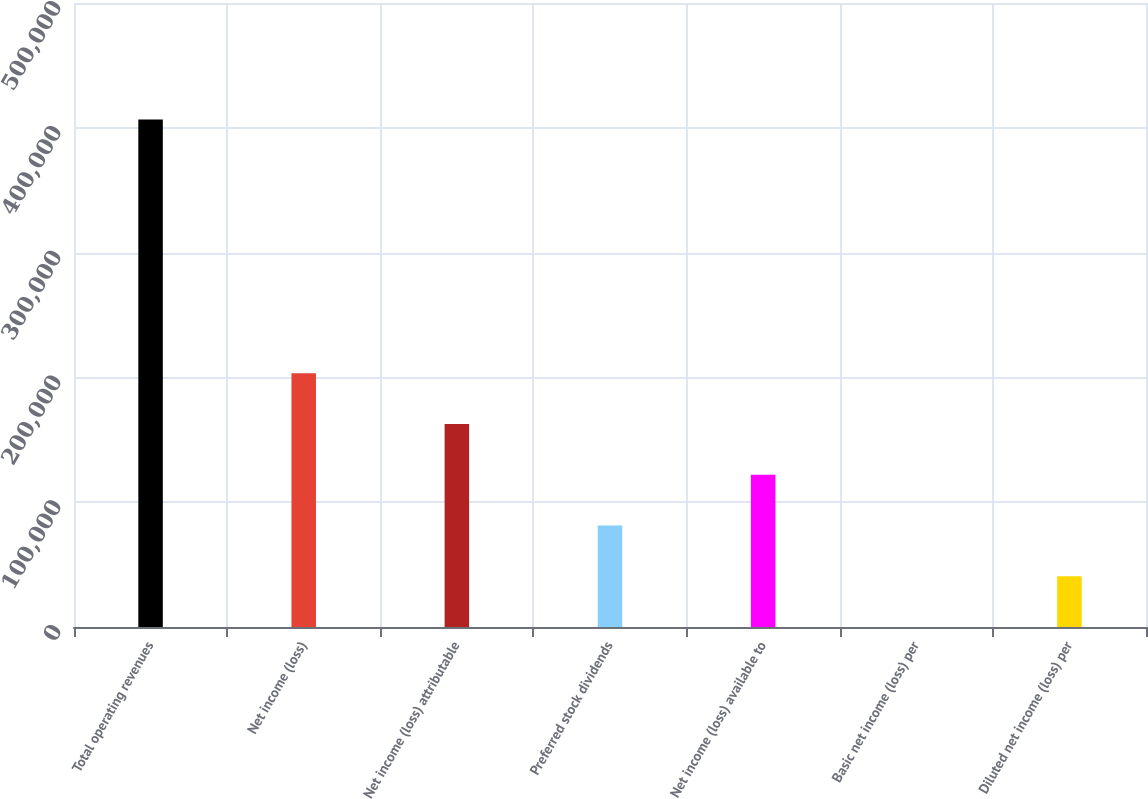Convert chart. <chart><loc_0><loc_0><loc_500><loc_500><bar_chart><fcel>Total operating revenues<fcel>Net income (loss)<fcel>Net income (loss) attributable<fcel>Preferred stock dividends<fcel>Net income (loss) available to<fcel>Basic net income (loss) per<fcel>Diluted net income (loss) per<nl><fcel>406609<fcel>203305<fcel>162644<fcel>81322.4<fcel>121983<fcel>0.75<fcel>40661.6<nl></chart> 